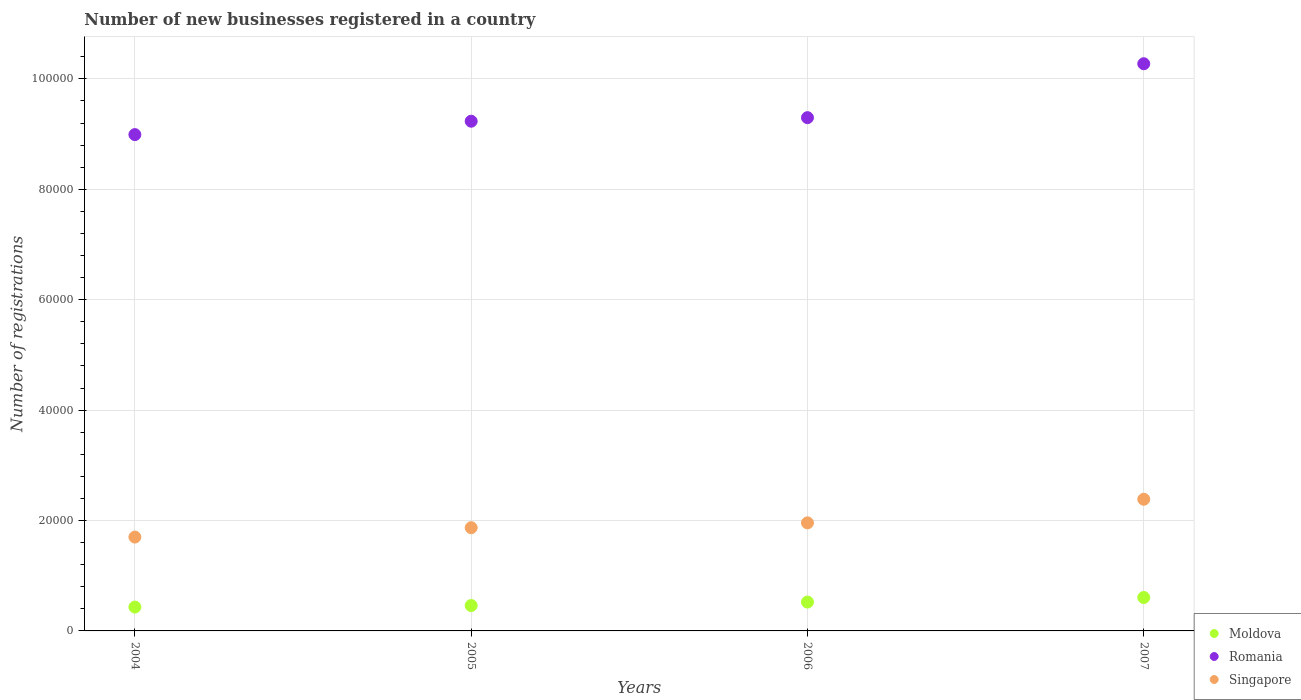How many different coloured dotlines are there?
Provide a succinct answer. 3. Is the number of dotlines equal to the number of legend labels?
Your response must be concise. Yes. What is the number of new businesses registered in Singapore in 2007?
Offer a terse response. 2.38e+04. Across all years, what is the maximum number of new businesses registered in Romania?
Offer a terse response. 1.03e+05. Across all years, what is the minimum number of new businesses registered in Singapore?
Offer a very short reply. 1.70e+04. In which year was the number of new businesses registered in Moldova maximum?
Keep it short and to the point. 2007. In which year was the number of new businesses registered in Singapore minimum?
Your response must be concise. 2004. What is the total number of new businesses registered in Moldova in the graph?
Your response must be concise. 2.02e+04. What is the difference between the number of new businesses registered in Singapore in 2005 and that in 2007?
Your answer should be very brief. -5149. What is the difference between the number of new businesses registered in Singapore in 2006 and the number of new businesses registered in Moldova in 2005?
Ensure brevity in your answer.  1.50e+04. What is the average number of new businesses registered in Moldova per year?
Provide a short and direct response. 5050.75. In the year 2004, what is the difference between the number of new businesses registered in Romania and number of new businesses registered in Moldova?
Make the answer very short. 8.56e+04. In how many years, is the number of new businesses registered in Singapore greater than 48000?
Your answer should be very brief. 0. What is the ratio of the number of new businesses registered in Moldova in 2006 to that in 2007?
Give a very brief answer. 0.86. Is the difference between the number of new businesses registered in Romania in 2005 and 2007 greater than the difference between the number of new businesses registered in Moldova in 2005 and 2007?
Provide a succinct answer. No. What is the difference between the highest and the second highest number of new businesses registered in Romania?
Make the answer very short. 9766. What is the difference between the highest and the lowest number of new businesses registered in Singapore?
Provide a short and direct response. 6849. Is the number of new businesses registered in Moldova strictly greater than the number of new businesses registered in Romania over the years?
Your answer should be compact. No. How many years are there in the graph?
Keep it short and to the point. 4. Are the values on the major ticks of Y-axis written in scientific E-notation?
Your response must be concise. No. Does the graph contain any zero values?
Give a very brief answer. No. Does the graph contain grids?
Make the answer very short. Yes. Where does the legend appear in the graph?
Give a very brief answer. Bottom right. How are the legend labels stacked?
Ensure brevity in your answer.  Vertical. What is the title of the graph?
Give a very brief answer. Number of new businesses registered in a country. What is the label or title of the Y-axis?
Your answer should be compact. Number of registrations. What is the Number of registrations of Moldova in 2004?
Provide a short and direct response. 4322. What is the Number of registrations in Romania in 2004?
Provide a succinct answer. 8.99e+04. What is the Number of registrations of Singapore in 2004?
Keep it short and to the point. 1.70e+04. What is the Number of registrations in Moldova in 2005?
Make the answer very short. 4598. What is the Number of registrations of Romania in 2005?
Your answer should be very brief. 9.23e+04. What is the Number of registrations in Singapore in 2005?
Give a very brief answer. 1.87e+04. What is the Number of registrations in Moldova in 2006?
Provide a short and direct response. 5227. What is the Number of registrations in Romania in 2006?
Provide a succinct answer. 9.30e+04. What is the Number of registrations in Singapore in 2006?
Offer a terse response. 1.96e+04. What is the Number of registrations of Moldova in 2007?
Make the answer very short. 6056. What is the Number of registrations of Romania in 2007?
Offer a very short reply. 1.03e+05. What is the Number of registrations in Singapore in 2007?
Provide a short and direct response. 2.38e+04. Across all years, what is the maximum Number of registrations in Moldova?
Your answer should be compact. 6056. Across all years, what is the maximum Number of registrations of Romania?
Your answer should be compact. 1.03e+05. Across all years, what is the maximum Number of registrations of Singapore?
Your response must be concise. 2.38e+04. Across all years, what is the minimum Number of registrations in Moldova?
Provide a short and direct response. 4322. Across all years, what is the minimum Number of registrations of Romania?
Provide a short and direct response. 8.99e+04. Across all years, what is the minimum Number of registrations in Singapore?
Your answer should be very brief. 1.70e+04. What is the total Number of registrations of Moldova in the graph?
Offer a very short reply. 2.02e+04. What is the total Number of registrations of Romania in the graph?
Provide a short and direct response. 3.78e+05. What is the total Number of registrations of Singapore in the graph?
Give a very brief answer. 7.91e+04. What is the difference between the Number of registrations of Moldova in 2004 and that in 2005?
Keep it short and to the point. -276. What is the difference between the Number of registrations in Romania in 2004 and that in 2005?
Provide a succinct answer. -2425. What is the difference between the Number of registrations of Singapore in 2004 and that in 2005?
Give a very brief answer. -1700. What is the difference between the Number of registrations of Moldova in 2004 and that in 2006?
Give a very brief answer. -905. What is the difference between the Number of registrations of Romania in 2004 and that in 2006?
Offer a very short reply. -3070. What is the difference between the Number of registrations in Singapore in 2004 and that in 2006?
Keep it short and to the point. -2574. What is the difference between the Number of registrations of Moldova in 2004 and that in 2007?
Give a very brief answer. -1734. What is the difference between the Number of registrations of Romania in 2004 and that in 2007?
Give a very brief answer. -1.28e+04. What is the difference between the Number of registrations in Singapore in 2004 and that in 2007?
Your response must be concise. -6849. What is the difference between the Number of registrations of Moldova in 2005 and that in 2006?
Offer a terse response. -629. What is the difference between the Number of registrations of Romania in 2005 and that in 2006?
Keep it short and to the point. -645. What is the difference between the Number of registrations in Singapore in 2005 and that in 2006?
Your answer should be very brief. -874. What is the difference between the Number of registrations in Moldova in 2005 and that in 2007?
Provide a succinct answer. -1458. What is the difference between the Number of registrations in Romania in 2005 and that in 2007?
Offer a very short reply. -1.04e+04. What is the difference between the Number of registrations of Singapore in 2005 and that in 2007?
Offer a very short reply. -5149. What is the difference between the Number of registrations of Moldova in 2006 and that in 2007?
Make the answer very short. -829. What is the difference between the Number of registrations of Romania in 2006 and that in 2007?
Ensure brevity in your answer.  -9766. What is the difference between the Number of registrations of Singapore in 2006 and that in 2007?
Your answer should be very brief. -4275. What is the difference between the Number of registrations in Moldova in 2004 and the Number of registrations in Romania in 2005?
Keep it short and to the point. -8.80e+04. What is the difference between the Number of registrations of Moldova in 2004 and the Number of registrations of Singapore in 2005?
Keep it short and to the point. -1.44e+04. What is the difference between the Number of registrations of Romania in 2004 and the Number of registrations of Singapore in 2005?
Your answer should be compact. 7.12e+04. What is the difference between the Number of registrations of Moldova in 2004 and the Number of registrations of Romania in 2006?
Offer a very short reply. -8.87e+04. What is the difference between the Number of registrations in Moldova in 2004 and the Number of registrations in Singapore in 2006?
Provide a succinct answer. -1.53e+04. What is the difference between the Number of registrations of Romania in 2004 and the Number of registrations of Singapore in 2006?
Give a very brief answer. 7.03e+04. What is the difference between the Number of registrations of Moldova in 2004 and the Number of registrations of Romania in 2007?
Give a very brief answer. -9.84e+04. What is the difference between the Number of registrations in Moldova in 2004 and the Number of registrations in Singapore in 2007?
Offer a very short reply. -1.95e+04. What is the difference between the Number of registrations of Romania in 2004 and the Number of registrations of Singapore in 2007?
Your response must be concise. 6.61e+04. What is the difference between the Number of registrations in Moldova in 2005 and the Number of registrations in Romania in 2006?
Your response must be concise. -8.84e+04. What is the difference between the Number of registrations in Moldova in 2005 and the Number of registrations in Singapore in 2006?
Give a very brief answer. -1.50e+04. What is the difference between the Number of registrations in Romania in 2005 and the Number of registrations in Singapore in 2006?
Offer a very short reply. 7.28e+04. What is the difference between the Number of registrations in Moldova in 2005 and the Number of registrations in Romania in 2007?
Offer a terse response. -9.81e+04. What is the difference between the Number of registrations in Moldova in 2005 and the Number of registrations in Singapore in 2007?
Ensure brevity in your answer.  -1.93e+04. What is the difference between the Number of registrations in Romania in 2005 and the Number of registrations in Singapore in 2007?
Offer a terse response. 6.85e+04. What is the difference between the Number of registrations of Moldova in 2006 and the Number of registrations of Romania in 2007?
Keep it short and to the point. -9.75e+04. What is the difference between the Number of registrations of Moldova in 2006 and the Number of registrations of Singapore in 2007?
Your answer should be very brief. -1.86e+04. What is the difference between the Number of registrations in Romania in 2006 and the Number of registrations in Singapore in 2007?
Ensure brevity in your answer.  6.91e+04. What is the average Number of registrations of Moldova per year?
Keep it short and to the point. 5050.75. What is the average Number of registrations of Romania per year?
Your answer should be very brief. 9.45e+04. What is the average Number of registrations of Singapore per year?
Keep it short and to the point. 1.98e+04. In the year 2004, what is the difference between the Number of registrations in Moldova and Number of registrations in Romania?
Give a very brief answer. -8.56e+04. In the year 2004, what is the difference between the Number of registrations in Moldova and Number of registrations in Singapore?
Offer a very short reply. -1.27e+04. In the year 2004, what is the difference between the Number of registrations in Romania and Number of registrations in Singapore?
Provide a succinct answer. 7.29e+04. In the year 2005, what is the difference between the Number of registrations in Moldova and Number of registrations in Romania?
Provide a short and direct response. -8.77e+04. In the year 2005, what is the difference between the Number of registrations of Moldova and Number of registrations of Singapore?
Offer a terse response. -1.41e+04. In the year 2005, what is the difference between the Number of registrations in Romania and Number of registrations in Singapore?
Make the answer very short. 7.36e+04. In the year 2006, what is the difference between the Number of registrations of Moldova and Number of registrations of Romania?
Give a very brief answer. -8.78e+04. In the year 2006, what is the difference between the Number of registrations in Moldova and Number of registrations in Singapore?
Provide a succinct answer. -1.43e+04. In the year 2006, what is the difference between the Number of registrations in Romania and Number of registrations in Singapore?
Provide a short and direct response. 7.34e+04. In the year 2007, what is the difference between the Number of registrations in Moldova and Number of registrations in Romania?
Your answer should be very brief. -9.67e+04. In the year 2007, what is the difference between the Number of registrations in Moldova and Number of registrations in Singapore?
Give a very brief answer. -1.78e+04. In the year 2007, what is the difference between the Number of registrations in Romania and Number of registrations in Singapore?
Offer a terse response. 7.89e+04. What is the ratio of the Number of registrations in Moldova in 2004 to that in 2005?
Ensure brevity in your answer.  0.94. What is the ratio of the Number of registrations in Romania in 2004 to that in 2005?
Your answer should be compact. 0.97. What is the ratio of the Number of registrations of Moldova in 2004 to that in 2006?
Your response must be concise. 0.83. What is the ratio of the Number of registrations of Romania in 2004 to that in 2006?
Provide a short and direct response. 0.97. What is the ratio of the Number of registrations of Singapore in 2004 to that in 2006?
Give a very brief answer. 0.87. What is the ratio of the Number of registrations of Moldova in 2004 to that in 2007?
Provide a short and direct response. 0.71. What is the ratio of the Number of registrations of Romania in 2004 to that in 2007?
Provide a succinct answer. 0.88. What is the ratio of the Number of registrations of Singapore in 2004 to that in 2007?
Your response must be concise. 0.71. What is the ratio of the Number of registrations of Moldova in 2005 to that in 2006?
Make the answer very short. 0.88. What is the ratio of the Number of registrations of Romania in 2005 to that in 2006?
Your answer should be very brief. 0.99. What is the ratio of the Number of registrations in Singapore in 2005 to that in 2006?
Provide a succinct answer. 0.96. What is the ratio of the Number of registrations of Moldova in 2005 to that in 2007?
Offer a very short reply. 0.76. What is the ratio of the Number of registrations of Romania in 2005 to that in 2007?
Your response must be concise. 0.9. What is the ratio of the Number of registrations in Singapore in 2005 to that in 2007?
Your response must be concise. 0.78. What is the ratio of the Number of registrations in Moldova in 2006 to that in 2007?
Ensure brevity in your answer.  0.86. What is the ratio of the Number of registrations in Romania in 2006 to that in 2007?
Keep it short and to the point. 0.9. What is the ratio of the Number of registrations in Singapore in 2006 to that in 2007?
Give a very brief answer. 0.82. What is the difference between the highest and the second highest Number of registrations of Moldova?
Provide a succinct answer. 829. What is the difference between the highest and the second highest Number of registrations in Romania?
Your answer should be very brief. 9766. What is the difference between the highest and the second highest Number of registrations of Singapore?
Your answer should be compact. 4275. What is the difference between the highest and the lowest Number of registrations of Moldova?
Your answer should be compact. 1734. What is the difference between the highest and the lowest Number of registrations in Romania?
Provide a succinct answer. 1.28e+04. What is the difference between the highest and the lowest Number of registrations of Singapore?
Your response must be concise. 6849. 